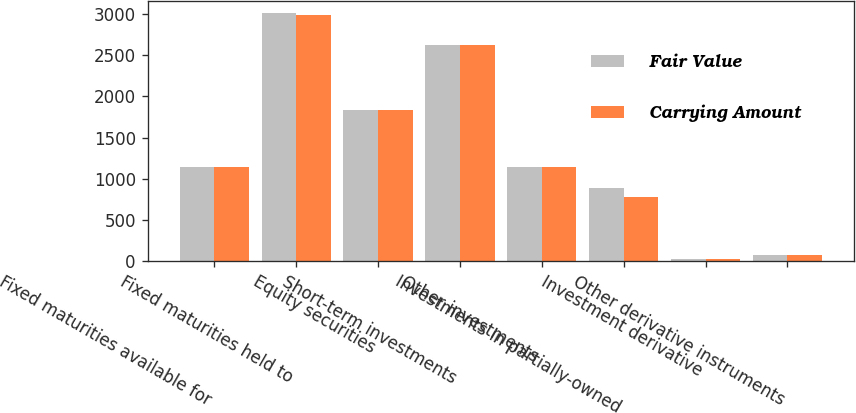Convert chart to OTSL. <chart><loc_0><loc_0><loc_500><loc_500><stacked_bar_chart><ecel><fcel>Fixed maturities available for<fcel>Fixed maturities held to<fcel>Equity securities<fcel>Short-term investments<fcel>Other investments<fcel>Investments in partially-owned<fcel>Investment derivative<fcel>Other derivative instruments<nl><fcel>Fair Value<fcel>1140<fcel>3015<fcel>1837<fcel>2631<fcel>1140<fcel>889<fcel>18<fcel>75<nl><fcel>Carrying Amount<fcel>1140<fcel>2987<fcel>1837<fcel>2631<fcel>1140<fcel>773<fcel>18<fcel>75<nl></chart> 